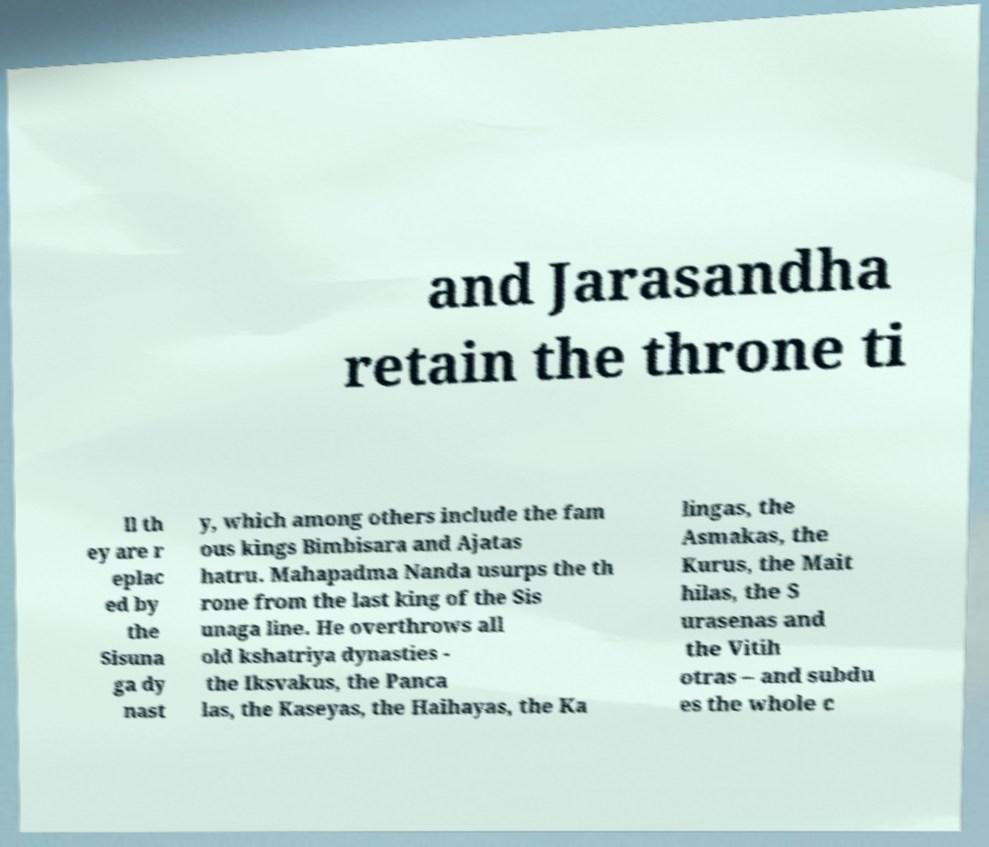Please read and relay the text visible in this image. What does it say? and Jarasandha retain the throne ti ll th ey are r eplac ed by the Sisuna ga dy nast y, which among others include the fam ous kings Bimbisara and Ajatas hatru. Mahapadma Nanda usurps the th rone from the last king of the Sis unaga line. He overthrows all old kshatriya dynasties - the Iksvakus, the Panca las, the Kaseyas, the Haihayas, the Ka lingas, the Asmakas, the Kurus, the Mait hilas, the S urasenas and the Vitih otras – and subdu es the whole c 